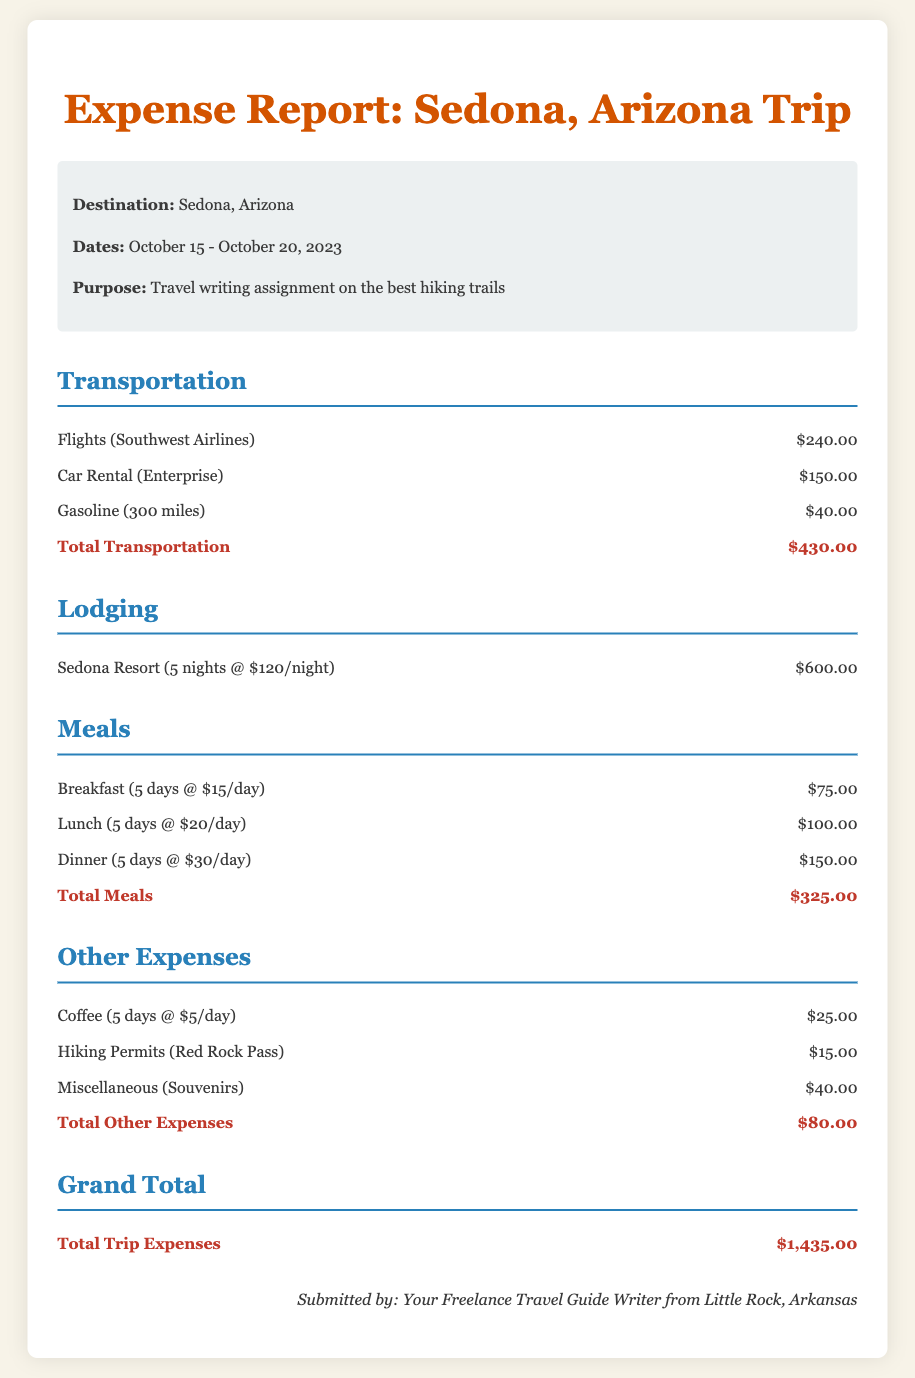What is the destination of the trip? The destination is clearly stated in the trip details section of the document.
Answer: Sedona, Arizona What are the dates of the trip? The dates can be found in the trip details section of the document.
Answer: October 15 - October 20, 2023 How much was spent on flights? The cost of flights is specified in the transportation section.
Answer: $240.00 What is the total cost for lodging? The cost for lodging is detailed in the lodging section of the document.
Answer: $600.00 What is the total amount spent on meals? The total for meals is provided in the meals section at the end of that section.
Answer: $325.00 How much was spent on gasoline? The amount for gasoline is mentioned in the transportation section.
Answer: $40.00 What is the grand total for the trip expenses? The grand total is summarized at the end of the document.
Answer: $1,435.00 What type of assignment was this trip for? The purpose of the trip is specified in the trip details.
Answer: Travel writing assignment on the best hiking trails How many nights did the lodging last? The number of nights is indicated in the lodging expense item.
Answer: 5 nights 